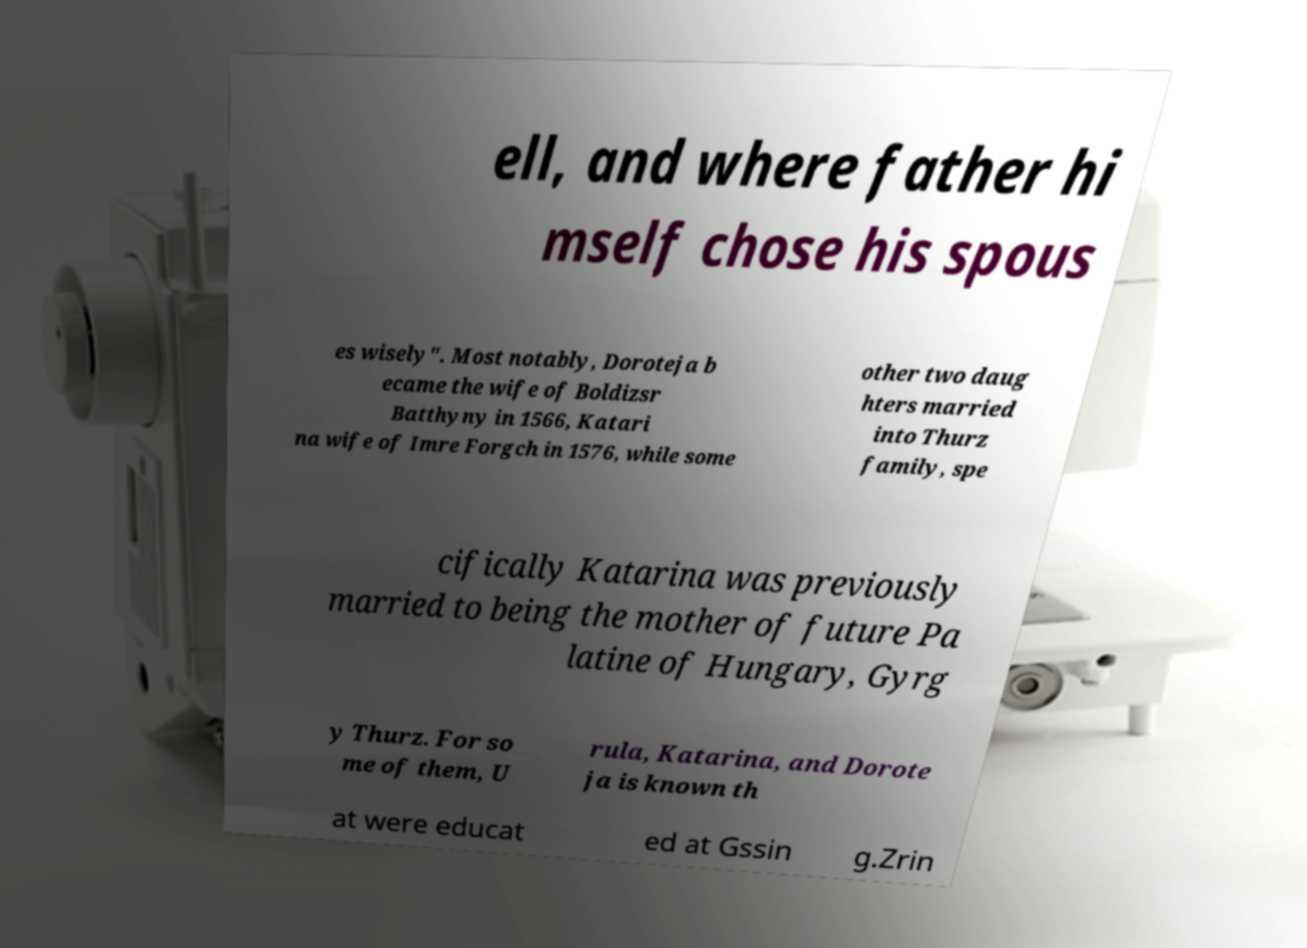For documentation purposes, I need the text within this image transcribed. Could you provide that? ell, and where father hi mself chose his spous es wisely". Most notably, Doroteja b ecame the wife of Boldizsr Batthyny in 1566, Katari na wife of Imre Forgch in 1576, while some other two daug hters married into Thurz family, spe cifically Katarina was previously married to being the mother of future Pa latine of Hungary, Gyrg y Thurz. For so me of them, U rula, Katarina, and Dorote ja is known th at were educat ed at Gssin g.Zrin 